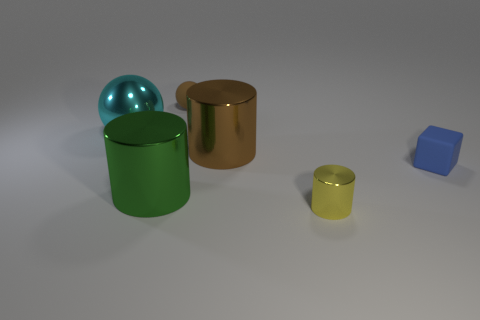Add 3 brown shiny objects. How many objects exist? 9 Subtract all large cylinders. How many cylinders are left? 1 Subtract 1 cylinders. How many cylinders are left? 2 Add 5 small yellow objects. How many small yellow objects are left? 6 Add 2 blue objects. How many blue objects exist? 3 Subtract all cyan spheres. How many spheres are left? 1 Subtract 0 purple spheres. How many objects are left? 6 Subtract all cubes. How many objects are left? 5 Subtract all green cubes. Subtract all blue cylinders. How many cubes are left? 1 Subtract all blue balls. How many blue cylinders are left? 0 